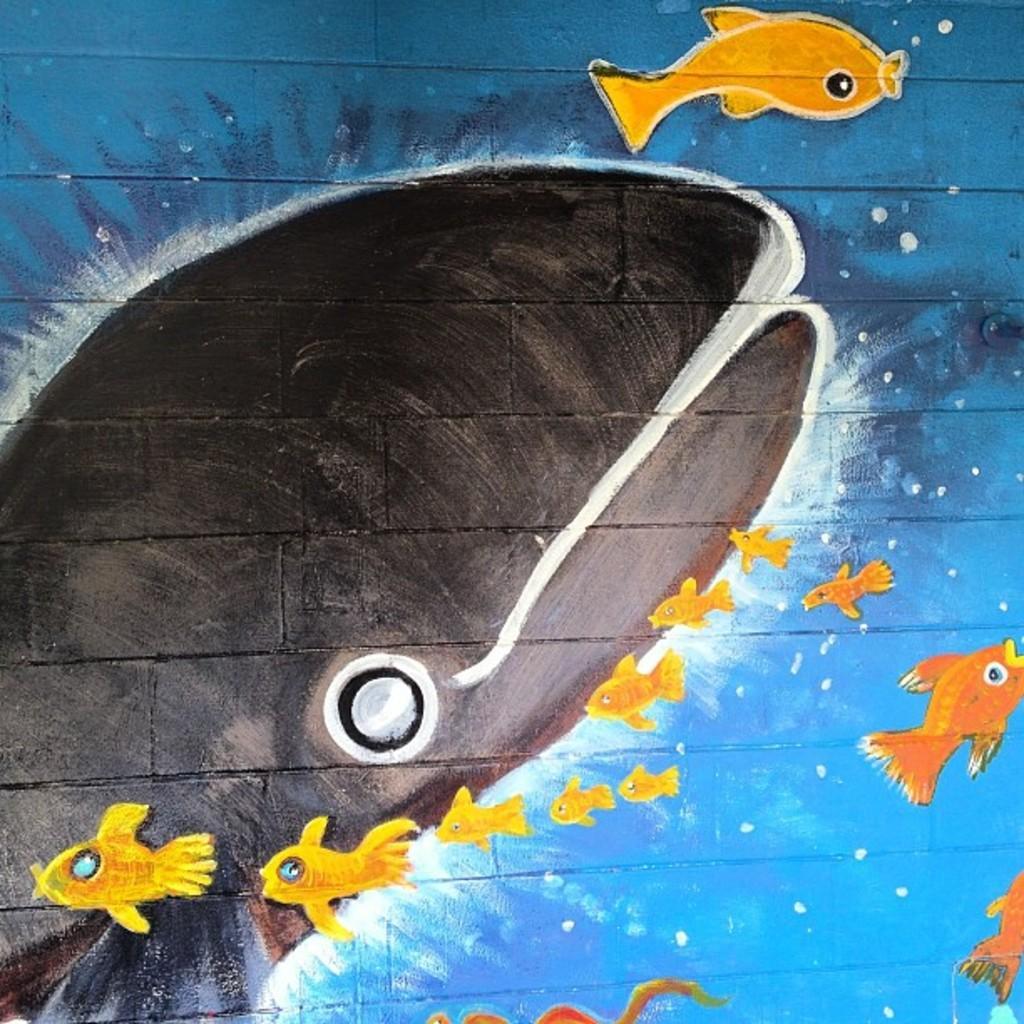Could you give a brief overview of what you see in this image? In this picture we can see a painting on the wall of fishes in the water. 